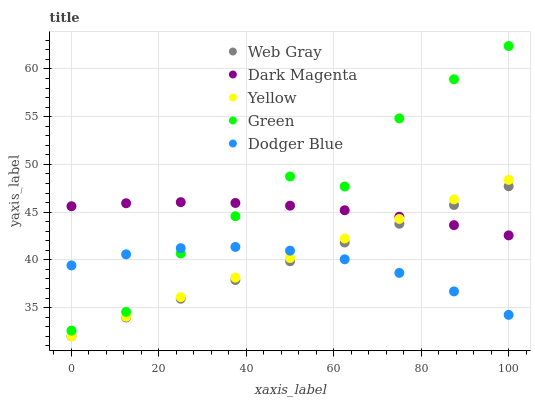Does Dodger Blue have the minimum area under the curve?
Answer yes or no. Yes. Does Green have the maximum area under the curve?
Answer yes or no. Yes. Does Web Gray have the minimum area under the curve?
Answer yes or no. No. Does Web Gray have the maximum area under the curve?
Answer yes or no. No. Is Web Gray the smoothest?
Answer yes or no. Yes. Is Green the roughest?
Answer yes or no. Yes. Is Green the smoothest?
Answer yes or no. No. Is Web Gray the roughest?
Answer yes or no. No. Does Web Gray have the lowest value?
Answer yes or no. Yes. Does Green have the lowest value?
Answer yes or no. No. Does Green have the highest value?
Answer yes or no. Yes. Does Web Gray have the highest value?
Answer yes or no. No. Is Web Gray less than Green?
Answer yes or no. Yes. Is Green greater than Yellow?
Answer yes or no. Yes. Does Dodger Blue intersect Green?
Answer yes or no. Yes. Is Dodger Blue less than Green?
Answer yes or no. No. Is Dodger Blue greater than Green?
Answer yes or no. No. Does Web Gray intersect Green?
Answer yes or no. No. 